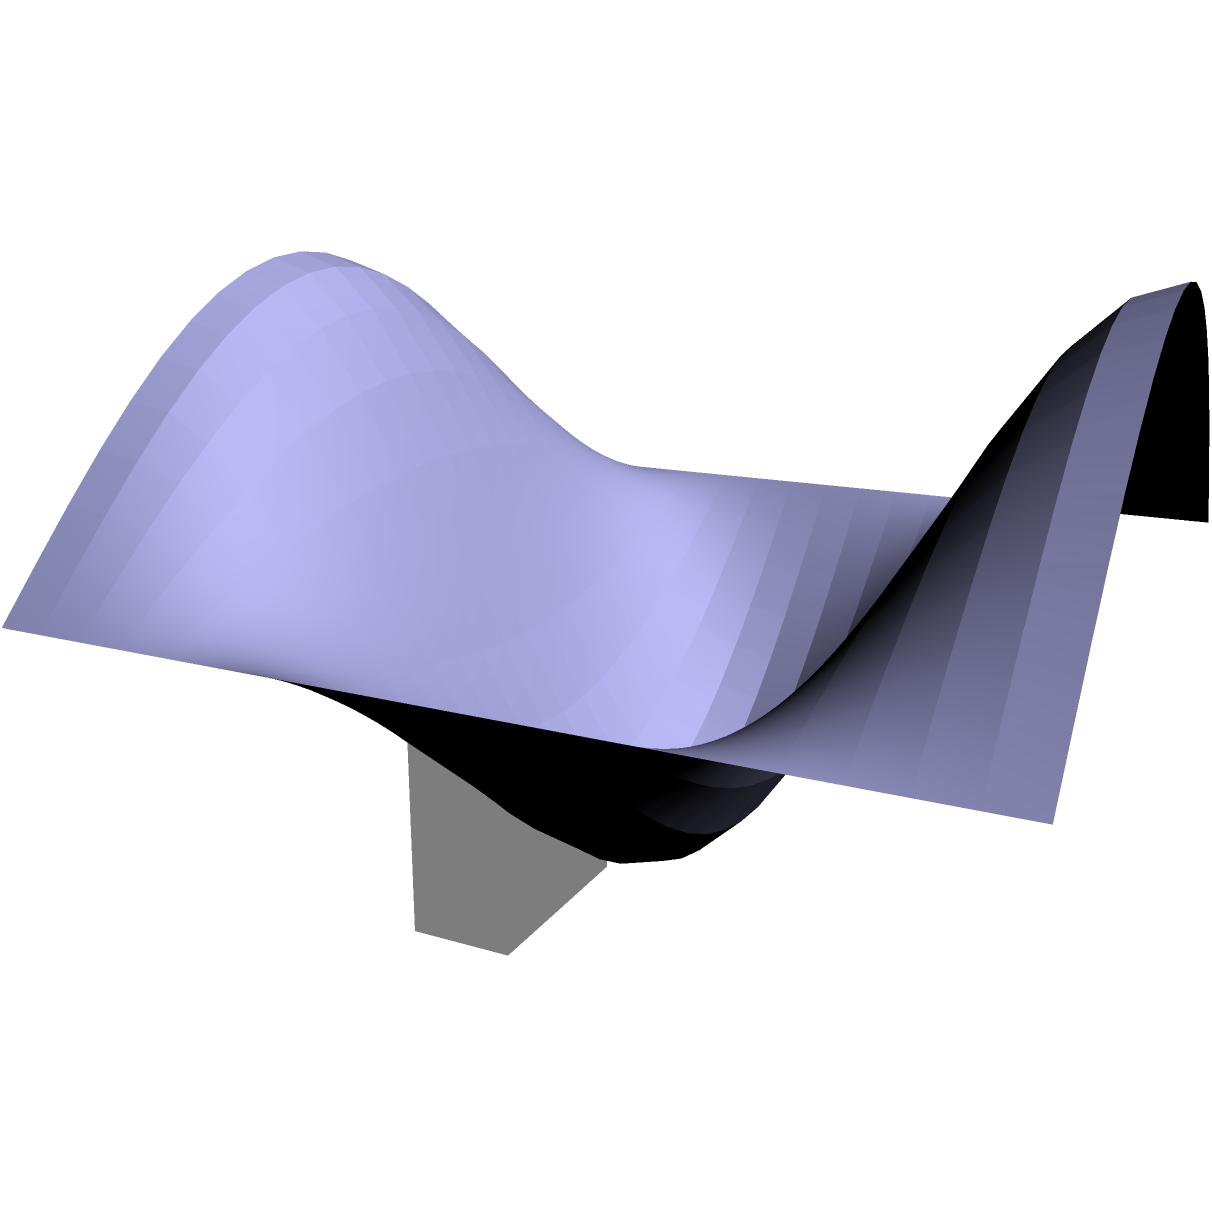In a game engine, you're tasked with determining the volume of a complex 3D object represented by the surface $z = 2 + \sin(x)\cos(y)$ over the region $0 \leq x \leq \pi$ and $0 \leq y \leq 2\pi$. How would you calculate this volume using calculus, and what is the result? To calculate the volume of this complex 3D object, we need to use a triple integral. Here's the step-by-step process:

1) The volume is given by the integral of the function over the specified region:

   $$V = \int_0^\pi \int_0^{2\pi} \int_0^{2+\sin(x)\cos(y)} dz dy dx$$

2) Evaluate the innermost integral with respect to z:

   $$V = \int_0^\pi \int_0^{2\pi} [2+\sin(x)\cos(y)] dy dx$$

3) Now, we need to integrate with respect to y. The integral of cos(y) over [0, 2π] is 0, so:

   $$V = \int_0^\pi \int_0^{2\pi} 2 dy dx + \int_0^\pi \int_0^{2\pi} \sin(x)\cos(y) dy dx$$
   $$V = \int_0^\pi 4\pi dx + 0$$

4) Finally, integrate with respect to x:

   $$V = 4\pi^2$$

Thus, the volume of the 3D object is $4\pi^2$ cubic units.
Answer: $4\pi^2$ cubic units 